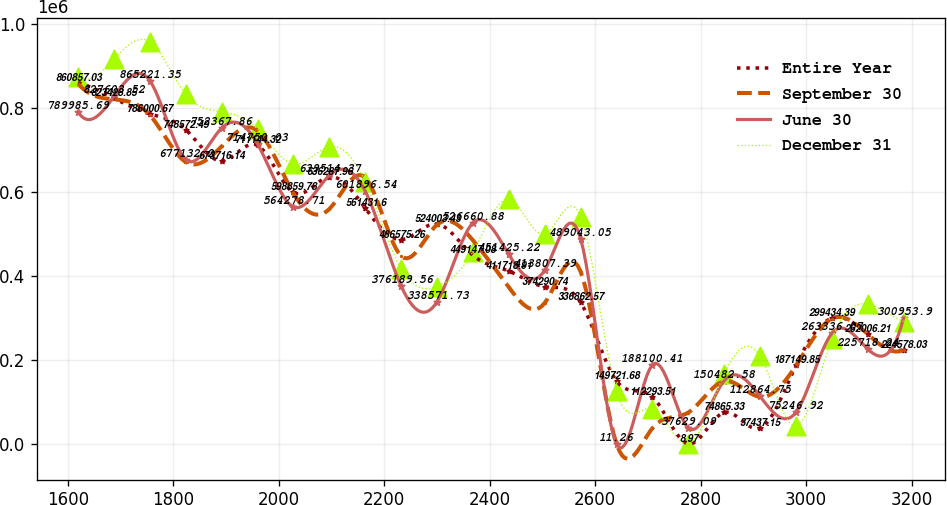<chart> <loc_0><loc_0><loc_500><loc_500><line_chart><ecel><fcel>Entire Year<fcel>September 30<fcel>June 30<fcel>December 31<nl><fcel>1619.31<fcel>860857<fcel>857960<fcel>789986<fcel>874315<nl><fcel>1687.38<fcel>823429<fcel>820658<fcel>827604<fcel>915948<nl><fcel>1755.45<fcel>786001<fcel>783355<fcel>865221<fcel>957582<nl><fcel>1823.52<fcel>748572<fcel>671449<fcel>677132<fcel>832681<nl><fcel>1891.59<fcel>673716<fcel>708751<fcel>752368<fcel>791048<nl><fcel>1959.66<fcel>711144<fcel>746053<fcel>714750<fcel>749414<nl><fcel>2027.73<fcel>598860<fcel>596844<fcel>564279<fcel>666147<nl><fcel>2095.8<fcel>636288<fcel>559542<fcel>639514<fcel>707781<nl><fcel>2163.87<fcel>561432<fcel>634147<fcel>601897<fcel>624513<nl><fcel>2231.94<fcel>486575<fcel>447636<fcel>376190<fcel>416345<nl><fcel>2300.01<fcel>524003<fcel>522240<fcel>338572<fcel>374712<nl><fcel>2368.08<fcel>449147<fcel>484938<fcel>526661<fcel>457979<nl><fcel>2436.15<fcel>411719<fcel>373031<fcel>451425<fcel>582880<nl><fcel>2504.22<fcel>374291<fcel>335729<fcel>413807<fcel>499613<nl><fcel>2572.29<fcel>336863<fcel>410333<fcel>489043<fcel>541246<nl><fcel>2640.36<fcel>149722<fcel>9.33<fcel>11.26<fcel>124910<nl><fcel>2708.43<fcel>112294<fcel>37311.5<fcel>188100<fcel>83276.7<nl><fcel>2776.5<fcel>8.97<fcel>74613.7<fcel>37629.1<fcel>9.57<nl><fcel>2844.57<fcel>74865.3<fcel>149218<fcel>150483<fcel>166544<nl><fcel>2912.64<fcel>37437.2<fcel>111916<fcel>112865<fcel>208178<nl><fcel>2980.71<fcel>187150<fcel>186520<fcel>75246.9<fcel>41643.2<nl><fcel>3048.78<fcel>299434<fcel>298427<fcel>263336<fcel>249811<nl><fcel>3116.85<fcel>262006<fcel>261125<fcel>225718<fcel>333078<nl><fcel>3184.92<fcel>224578<fcel>223822<fcel>300954<fcel>291445<nl></chart> 